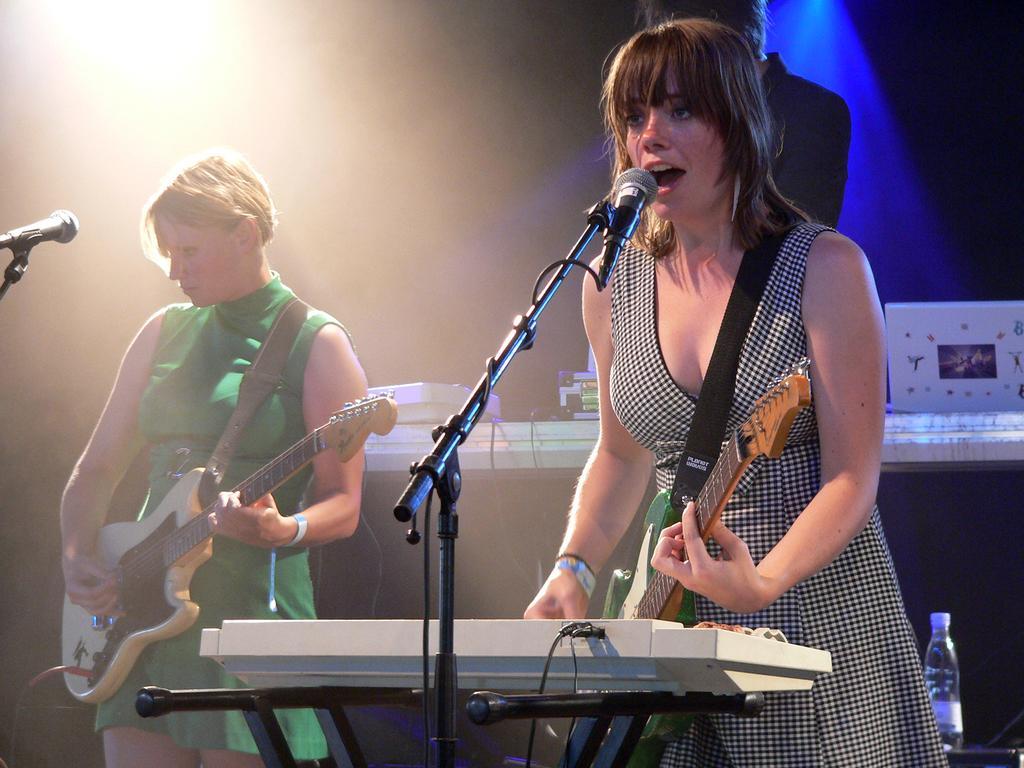How would you summarize this image in a sentence or two? In the image we can see there are people standing and they are holding guitar in their hand. There are mics with a stand and there are pianos. 